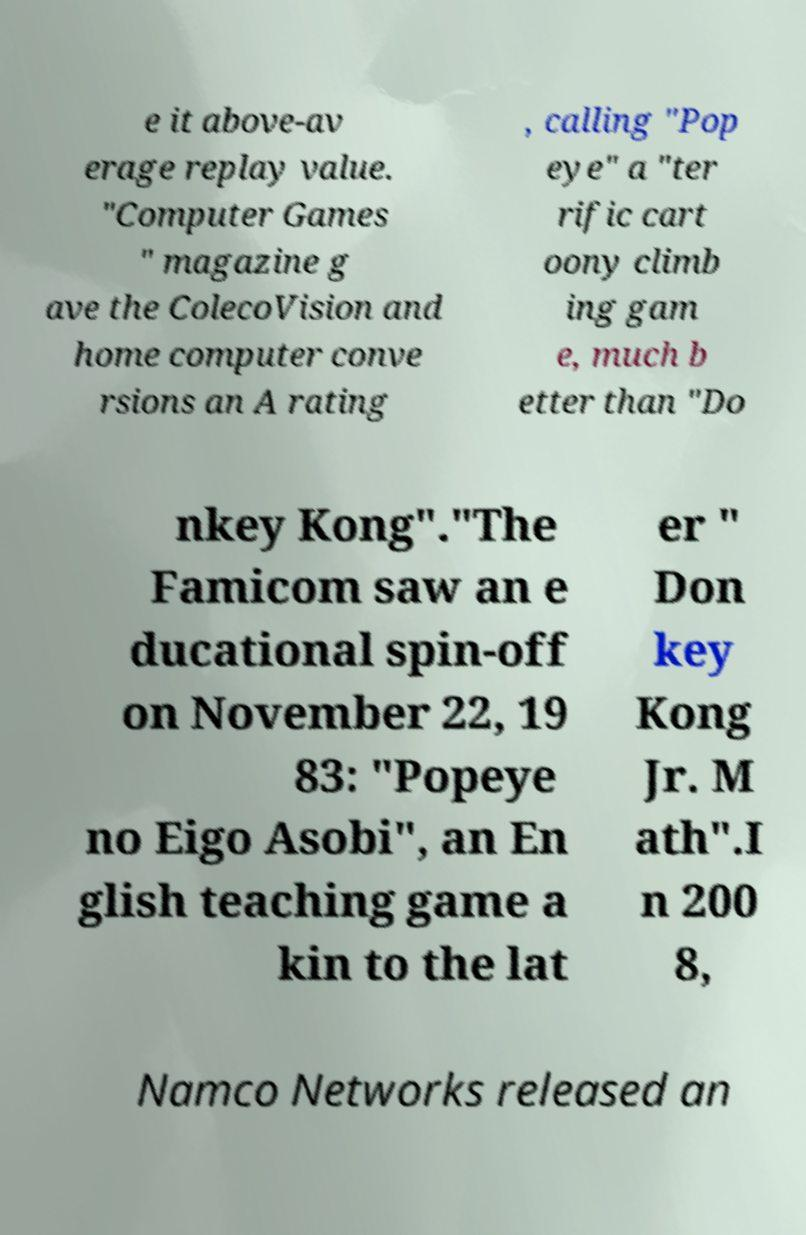Could you assist in decoding the text presented in this image and type it out clearly? e it above-av erage replay value. "Computer Games " magazine g ave the ColecoVision and home computer conve rsions an A rating , calling "Pop eye" a "ter rific cart oony climb ing gam e, much b etter than "Do nkey Kong"."The Famicom saw an e ducational spin-off on November 22, 19 83: "Popeye no Eigo Asobi", an En glish teaching game a kin to the lat er " Don key Kong Jr. M ath".I n 200 8, Namco Networks released an 